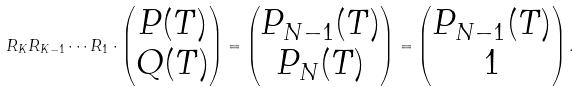<formula> <loc_0><loc_0><loc_500><loc_500>R _ { K } R _ { K - 1 } \cdots R _ { 1 } \cdot \begin{pmatrix} P ( T ) \\ Q ( T ) \end{pmatrix} = \begin{pmatrix} P _ { N - 1 } ( T ) \\ P _ { N } ( T ) \end{pmatrix} = \begin{pmatrix} P _ { N - 1 } ( T ) \\ 1 \end{pmatrix} .</formula> 